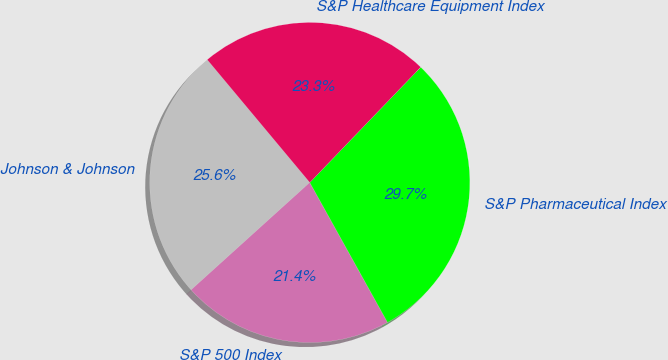<chart> <loc_0><loc_0><loc_500><loc_500><pie_chart><fcel>Johnson & Johnson<fcel>S&P 500 Index<fcel>S&P Pharmaceutical Index<fcel>S&P Healthcare Equipment Index<nl><fcel>25.63%<fcel>21.37%<fcel>29.74%<fcel>23.26%<nl></chart> 